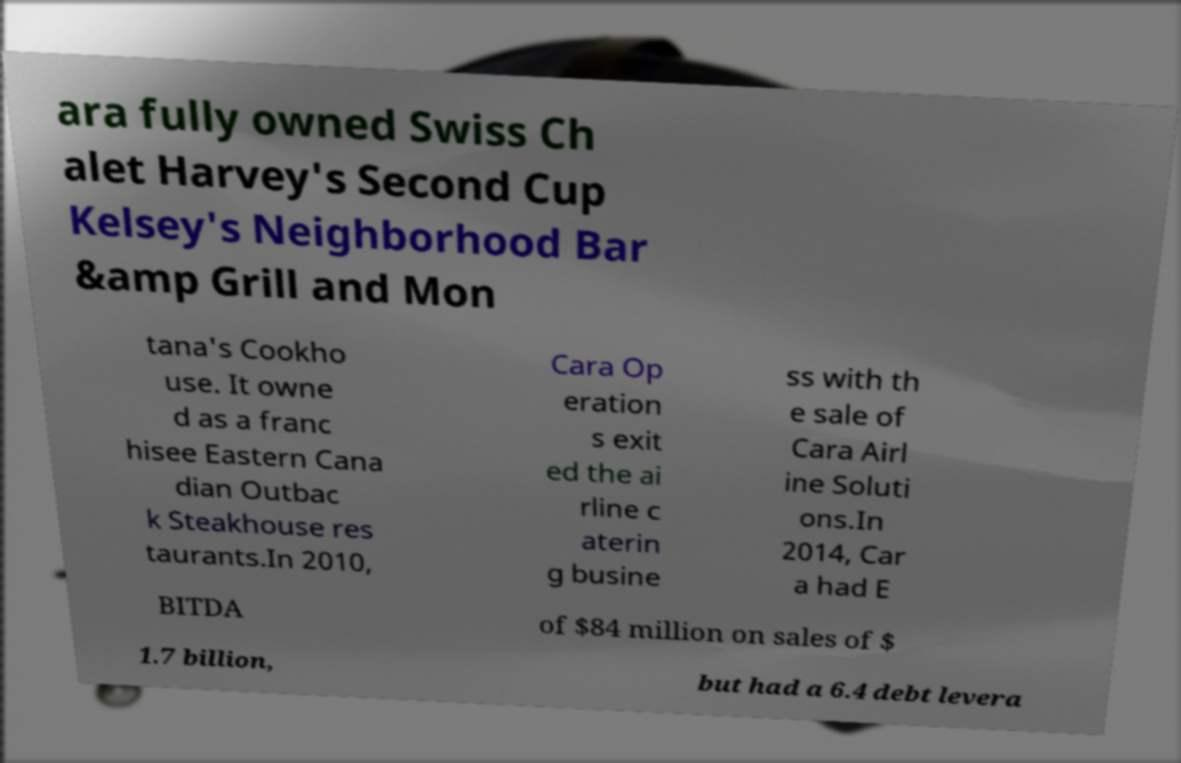For documentation purposes, I need the text within this image transcribed. Could you provide that? ara fully owned Swiss Ch alet Harvey's Second Cup Kelsey's Neighborhood Bar &amp Grill and Mon tana's Cookho use. It owne d as a franc hisee Eastern Cana dian Outbac k Steakhouse res taurants.In 2010, Cara Op eration s exit ed the ai rline c aterin g busine ss with th e sale of Cara Airl ine Soluti ons.In 2014, Car a had E BITDA of $84 million on sales of $ 1.7 billion, but had a 6.4 debt levera 